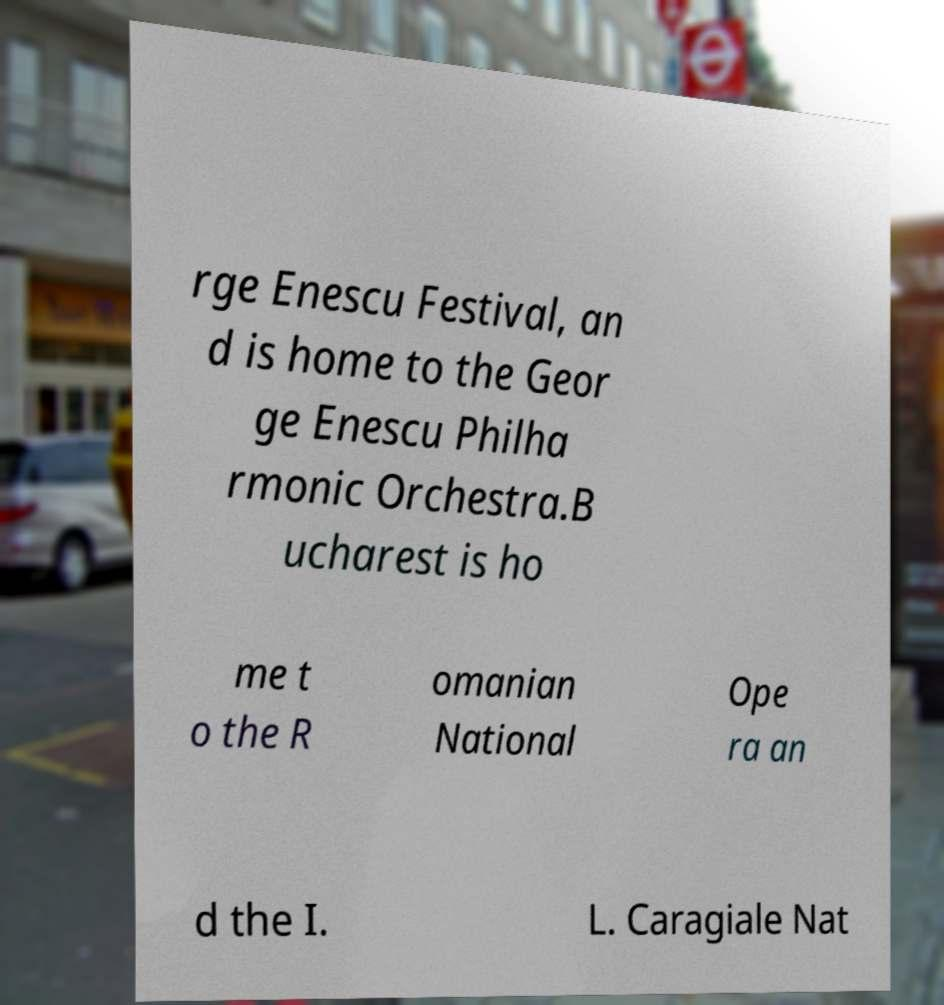For documentation purposes, I need the text within this image transcribed. Could you provide that? rge Enescu Festival, an d is home to the Geor ge Enescu Philha rmonic Orchestra.B ucharest is ho me t o the R omanian National Ope ra an d the I. L. Caragiale Nat 